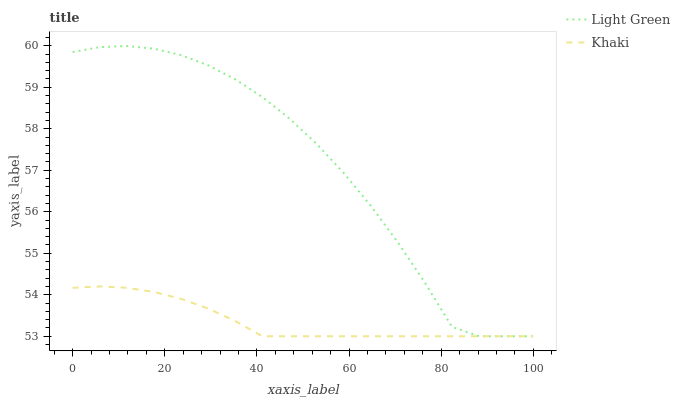Does Khaki have the minimum area under the curve?
Answer yes or no. Yes. Does Light Green have the maximum area under the curve?
Answer yes or no. Yes. Does Light Green have the minimum area under the curve?
Answer yes or no. No. Is Khaki the smoothest?
Answer yes or no. Yes. Is Light Green the roughest?
Answer yes or no. Yes. Is Light Green the smoothest?
Answer yes or no. No. Does Khaki have the lowest value?
Answer yes or no. Yes. Does Light Green have the highest value?
Answer yes or no. Yes. Does Khaki intersect Light Green?
Answer yes or no. Yes. Is Khaki less than Light Green?
Answer yes or no. No. Is Khaki greater than Light Green?
Answer yes or no. No. 